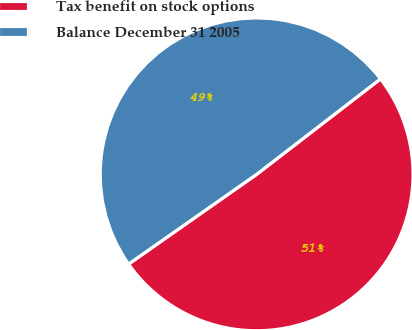Convert chart. <chart><loc_0><loc_0><loc_500><loc_500><pie_chart><fcel>Tax benefit on stock options<fcel>Balance December 31 2005<nl><fcel>50.72%<fcel>49.28%<nl></chart> 